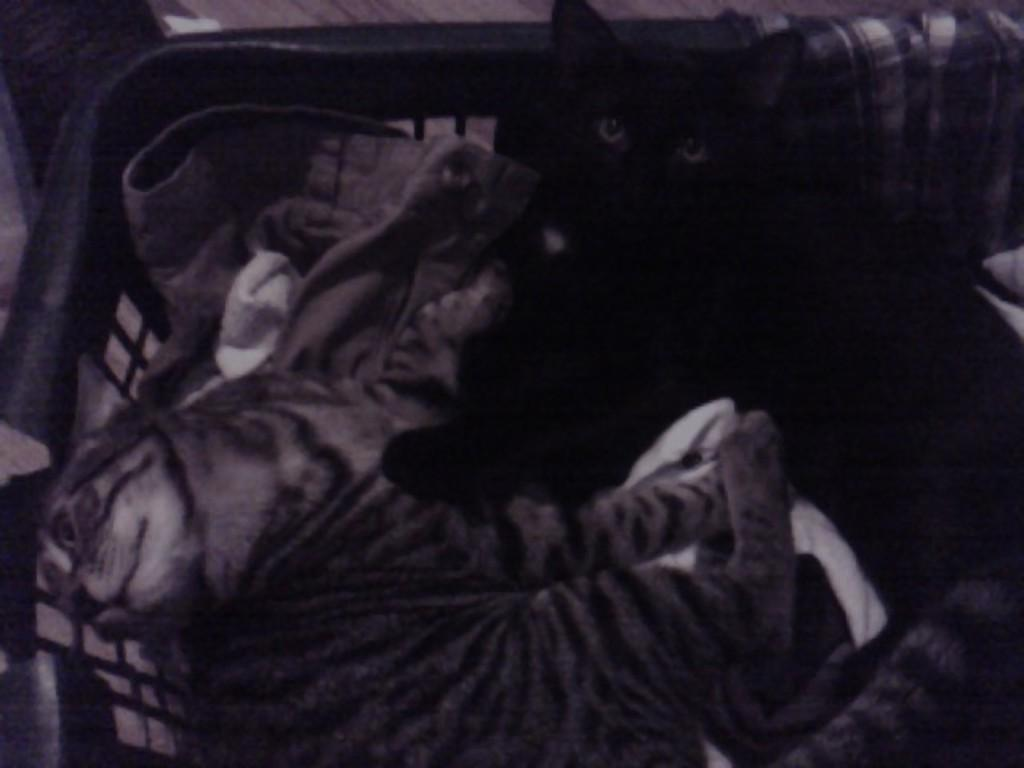What type of animals are in the image? There are cats in the image. What colors are the cats? The cats are black and brown in color. Where are the cats located in the image? The cats are in a tub. What else is in the tub with the cats? There are clothes in the tub. How do the cats expand their knowledge while in the tub? The cats are not shown to be expanding their knowledge in the image, and there is no indication of any educational activity taking place. 